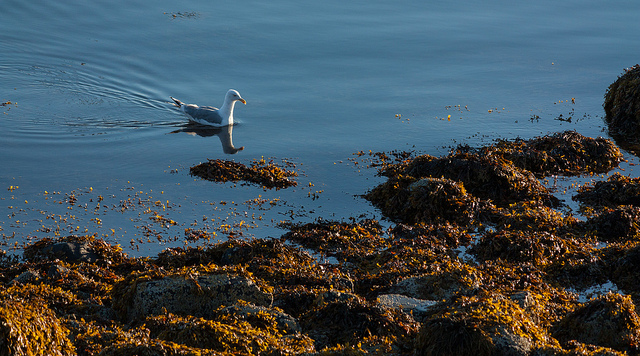How many animals are pictured? 1 